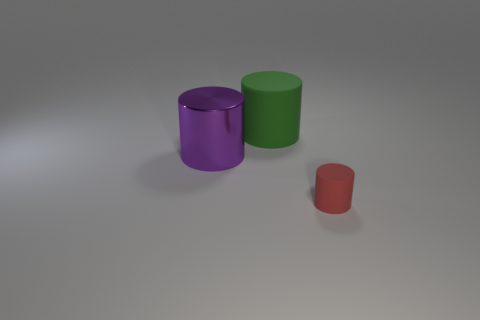Add 3 blue rubber cylinders. How many objects exist? 6 Subtract 0 gray spheres. How many objects are left? 3 Subtract all purple metallic objects. Subtract all small rubber spheres. How many objects are left? 2 Add 1 purple cylinders. How many purple cylinders are left? 2 Add 3 large purple things. How many large purple things exist? 4 